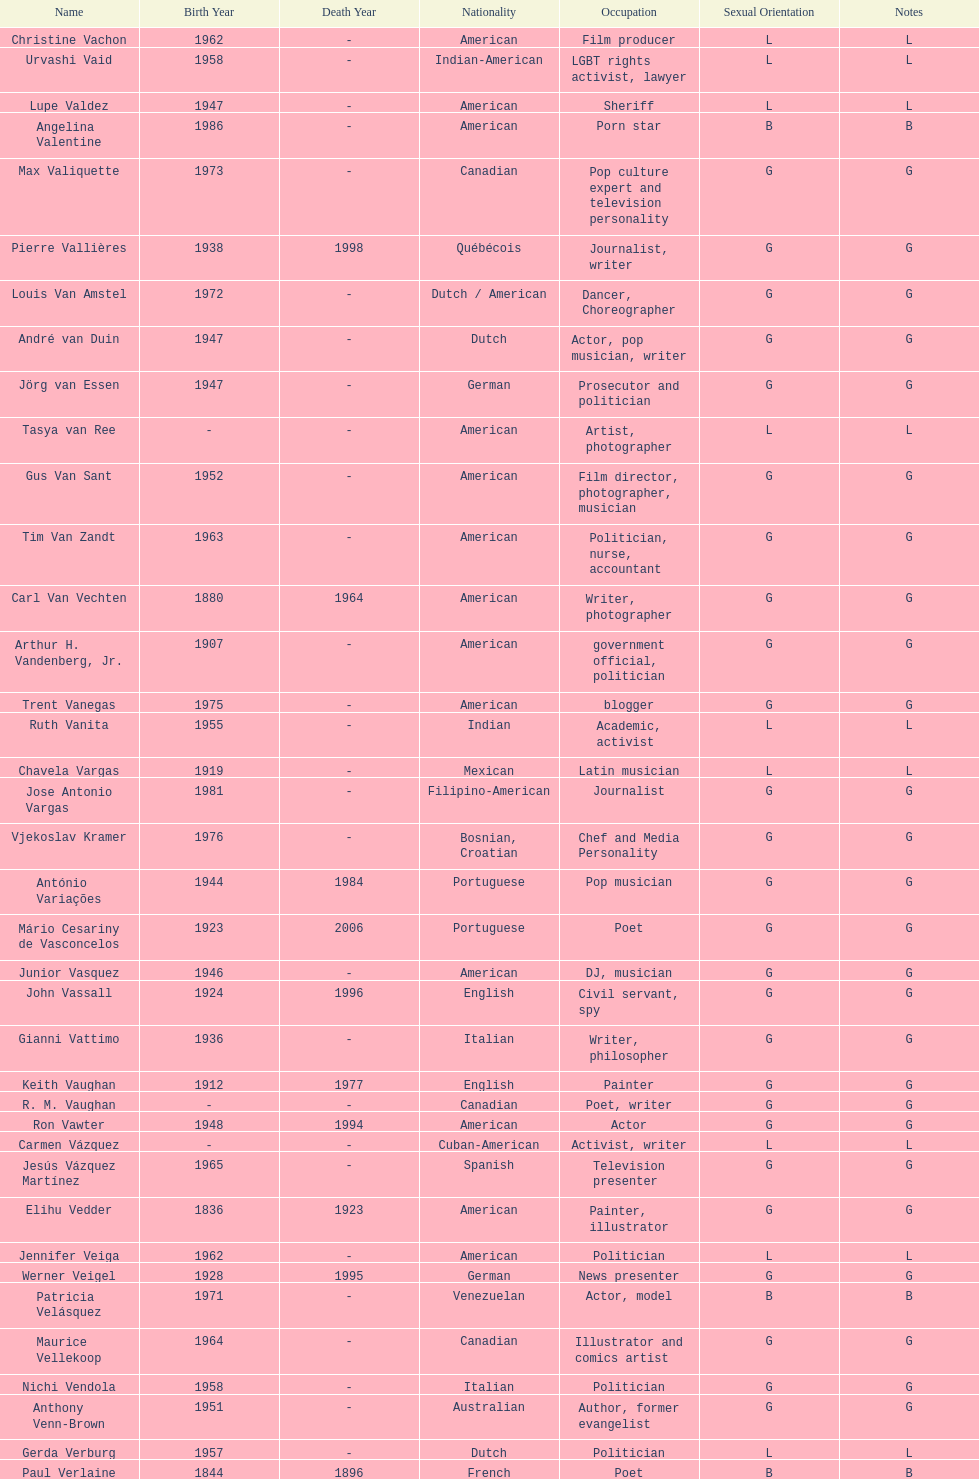What is the difference in year of borth between vachon and vaid? 4 years. 